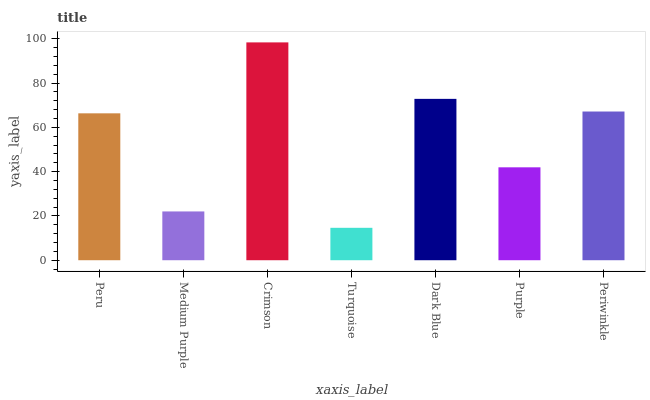Is Turquoise the minimum?
Answer yes or no. Yes. Is Crimson the maximum?
Answer yes or no. Yes. Is Medium Purple the minimum?
Answer yes or no. No. Is Medium Purple the maximum?
Answer yes or no. No. Is Peru greater than Medium Purple?
Answer yes or no. Yes. Is Medium Purple less than Peru?
Answer yes or no. Yes. Is Medium Purple greater than Peru?
Answer yes or no. No. Is Peru less than Medium Purple?
Answer yes or no. No. Is Peru the high median?
Answer yes or no. Yes. Is Peru the low median?
Answer yes or no. Yes. Is Dark Blue the high median?
Answer yes or no. No. Is Turquoise the low median?
Answer yes or no. No. 